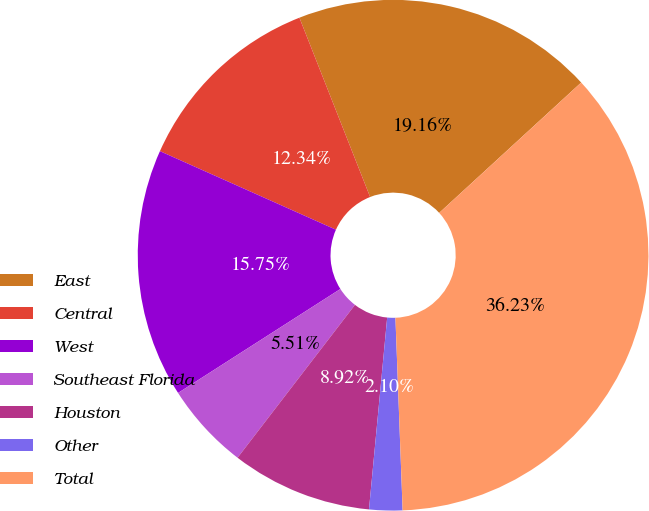<chart> <loc_0><loc_0><loc_500><loc_500><pie_chart><fcel>East<fcel>Central<fcel>West<fcel>Southeast Florida<fcel>Houston<fcel>Other<fcel>Total<nl><fcel>19.16%<fcel>12.34%<fcel>15.75%<fcel>5.51%<fcel>8.92%<fcel>2.1%<fcel>36.23%<nl></chart> 